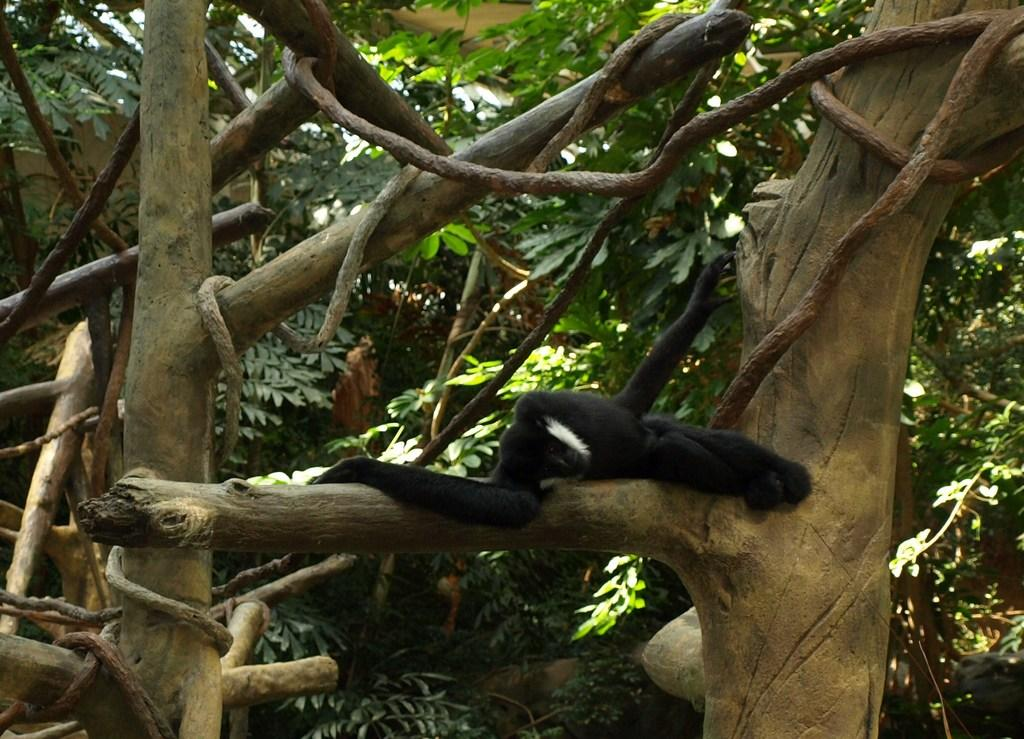What type of vegetation can be seen in the image? There are trees in the image. Is there any wildlife present in the image? Yes, there is an animal on one of the trees. What is the color of the animal in the image? The animal is black in color. How does the animal interact with the calendar in the image? There is no calendar present in the image, so the animal cannot interact with it. 